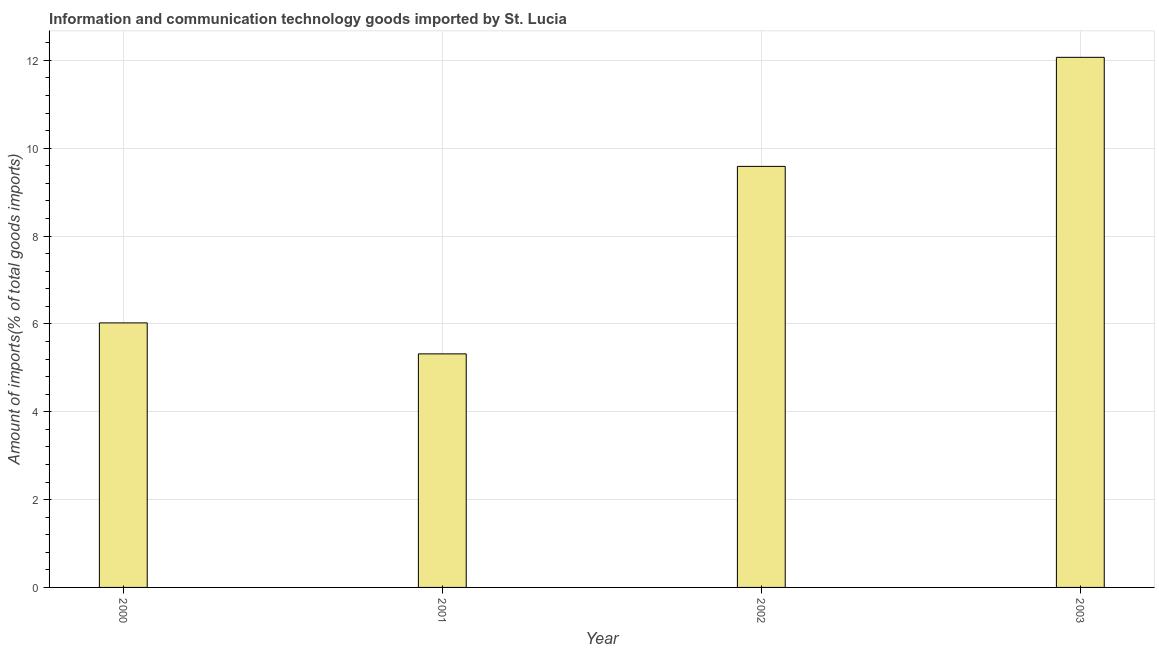What is the title of the graph?
Give a very brief answer. Information and communication technology goods imported by St. Lucia. What is the label or title of the X-axis?
Provide a short and direct response. Year. What is the label or title of the Y-axis?
Keep it short and to the point. Amount of imports(% of total goods imports). What is the amount of ict goods imports in 2000?
Offer a terse response. 6.02. Across all years, what is the maximum amount of ict goods imports?
Offer a very short reply. 12.07. Across all years, what is the minimum amount of ict goods imports?
Make the answer very short. 5.32. In which year was the amount of ict goods imports minimum?
Your answer should be compact. 2001. What is the sum of the amount of ict goods imports?
Give a very brief answer. 33. What is the difference between the amount of ict goods imports in 2001 and 2002?
Keep it short and to the point. -4.27. What is the average amount of ict goods imports per year?
Your response must be concise. 8.25. What is the median amount of ict goods imports?
Keep it short and to the point. 7.8. In how many years, is the amount of ict goods imports greater than 8.8 %?
Your answer should be compact. 2. What is the ratio of the amount of ict goods imports in 2001 to that in 2003?
Your answer should be compact. 0.44. Is the amount of ict goods imports in 2001 less than that in 2002?
Give a very brief answer. Yes. What is the difference between the highest and the second highest amount of ict goods imports?
Keep it short and to the point. 2.48. Is the sum of the amount of ict goods imports in 2001 and 2003 greater than the maximum amount of ict goods imports across all years?
Keep it short and to the point. Yes. What is the difference between the highest and the lowest amount of ict goods imports?
Your answer should be compact. 6.75. In how many years, is the amount of ict goods imports greater than the average amount of ict goods imports taken over all years?
Your answer should be compact. 2. How many bars are there?
Your answer should be very brief. 4. Are all the bars in the graph horizontal?
Offer a very short reply. No. What is the difference between two consecutive major ticks on the Y-axis?
Your response must be concise. 2. Are the values on the major ticks of Y-axis written in scientific E-notation?
Your answer should be very brief. No. What is the Amount of imports(% of total goods imports) of 2000?
Your answer should be compact. 6.02. What is the Amount of imports(% of total goods imports) of 2001?
Ensure brevity in your answer.  5.32. What is the Amount of imports(% of total goods imports) in 2002?
Provide a succinct answer. 9.59. What is the Amount of imports(% of total goods imports) in 2003?
Keep it short and to the point. 12.07. What is the difference between the Amount of imports(% of total goods imports) in 2000 and 2001?
Offer a terse response. 0.71. What is the difference between the Amount of imports(% of total goods imports) in 2000 and 2002?
Provide a short and direct response. -3.56. What is the difference between the Amount of imports(% of total goods imports) in 2000 and 2003?
Your response must be concise. -6.05. What is the difference between the Amount of imports(% of total goods imports) in 2001 and 2002?
Your response must be concise. -4.27. What is the difference between the Amount of imports(% of total goods imports) in 2001 and 2003?
Your response must be concise. -6.75. What is the difference between the Amount of imports(% of total goods imports) in 2002 and 2003?
Provide a succinct answer. -2.48. What is the ratio of the Amount of imports(% of total goods imports) in 2000 to that in 2001?
Offer a terse response. 1.13. What is the ratio of the Amount of imports(% of total goods imports) in 2000 to that in 2002?
Your answer should be very brief. 0.63. What is the ratio of the Amount of imports(% of total goods imports) in 2000 to that in 2003?
Your response must be concise. 0.5. What is the ratio of the Amount of imports(% of total goods imports) in 2001 to that in 2002?
Provide a short and direct response. 0.56. What is the ratio of the Amount of imports(% of total goods imports) in 2001 to that in 2003?
Your answer should be very brief. 0.44. What is the ratio of the Amount of imports(% of total goods imports) in 2002 to that in 2003?
Your answer should be very brief. 0.79. 